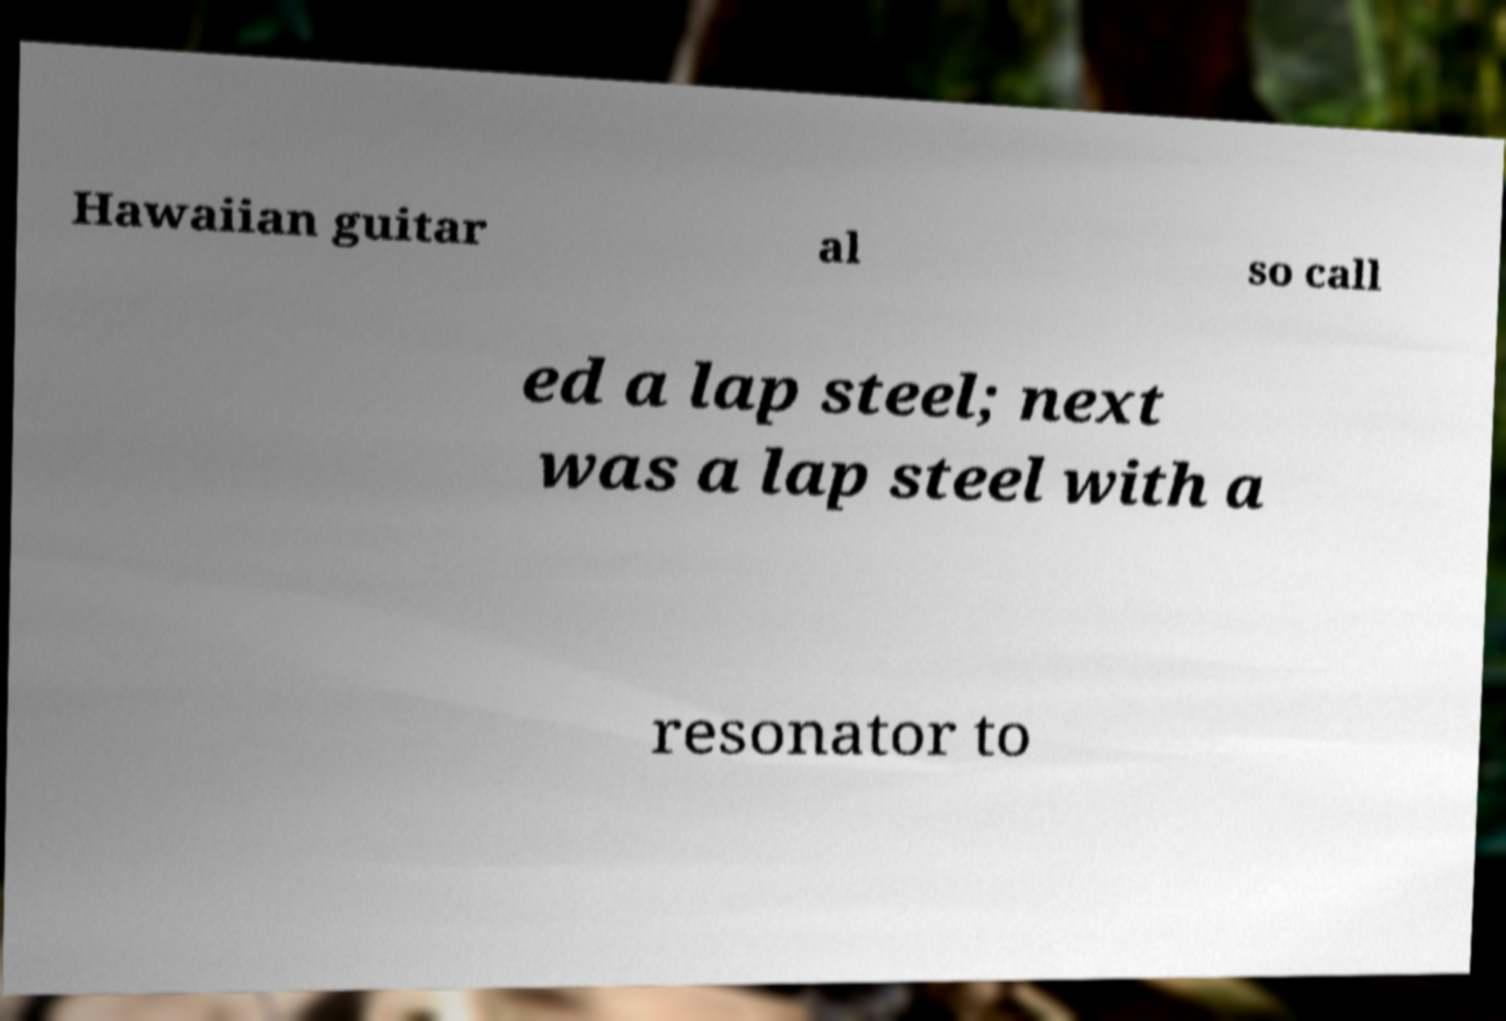Could you assist in decoding the text presented in this image and type it out clearly? Hawaiian guitar al so call ed a lap steel; next was a lap steel with a resonator to 